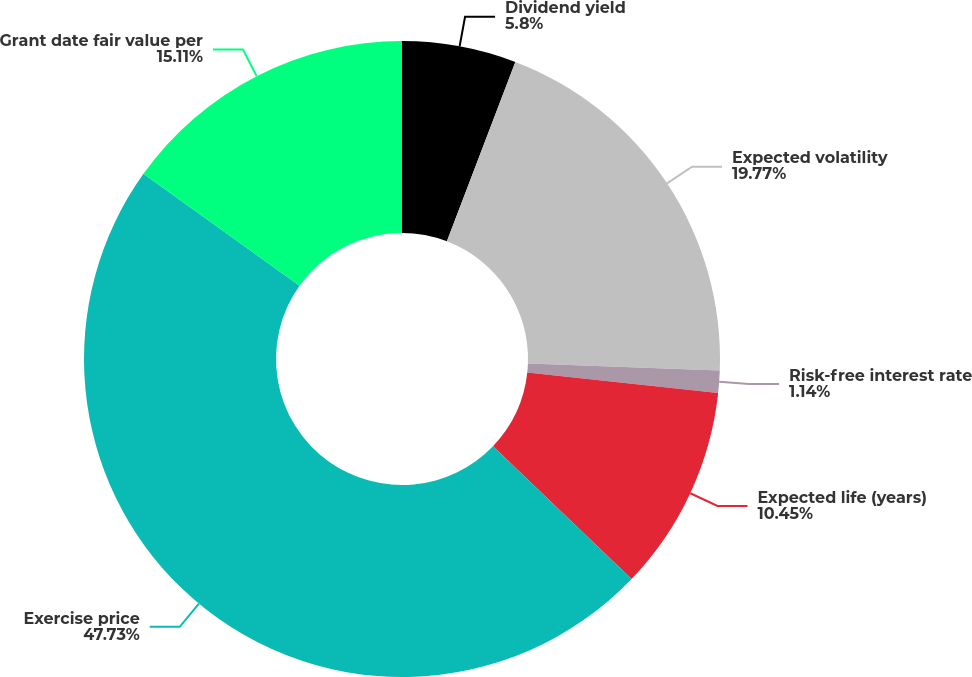Convert chart. <chart><loc_0><loc_0><loc_500><loc_500><pie_chart><fcel>Dividend yield<fcel>Expected volatility<fcel>Risk-free interest rate<fcel>Expected life (years)<fcel>Exercise price<fcel>Grant date fair value per<nl><fcel>5.8%<fcel>19.77%<fcel>1.14%<fcel>10.45%<fcel>47.73%<fcel>15.11%<nl></chart> 